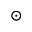Convert formula to latex. <formula><loc_0><loc_0><loc_500><loc_500>\odot</formula> 